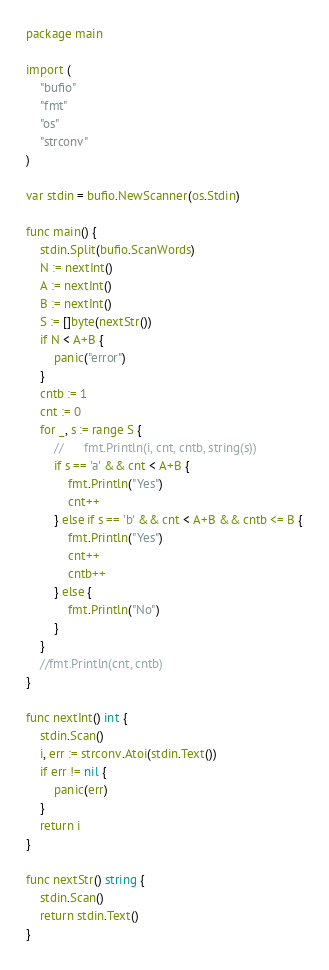Convert code to text. <code><loc_0><loc_0><loc_500><loc_500><_Go_>package main

import (
	"bufio"
	"fmt"
	"os"
	"strconv"
)

var stdin = bufio.NewScanner(os.Stdin)

func main() {
	stdin.Split(bufio.ScanWords)
	N := nextInt()
	A := nextInt()
	B := nextInt()
	S := []byte(nextStr())
	if N < A+B {
		panic("error")
	}
	cntb := 1
	cnt := 0
	for _, s := range S {
		//		fmt.Println(i, cnt, cntb, string(s))
		if s == 'a' && cnt < A+B {
			fmt.Println("Yes")
			cnt++
		} else if s == 'b' && cnt < A+B && cntb <= B {
			fmt.Println("Yes")
			cnt++
			cntb++
		} else {
			fmt.Println("No")
		}
	}
	//fmt.Println(cnt, cntb)
}

func nextInt() int {
	stdin.Scan()
	i, err := strconv.Atoi(stdin.Text())
	if err != nil {
		panic(err)
	}
	return i
}

func nextStr() string {
	stdin.Scan()
	return stdin.Text()
}
</code> 